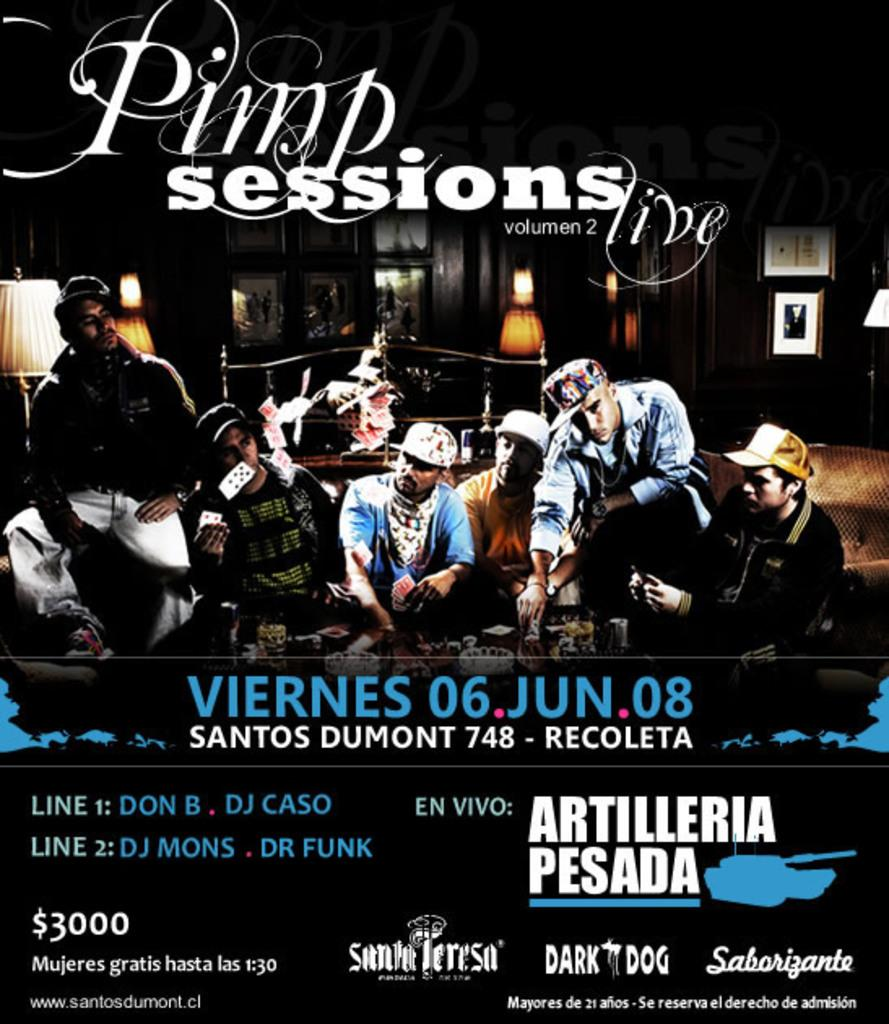<image>
Share a concise interpretation of the image provided. A volume 2 of Pimp Sessions live on viernes 06 jun 08. 